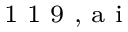Convert formula to latex. <formula><loc_0><loc_0><loc_500><loc_500>^ { 1 } 1 9 , a i</formula> 